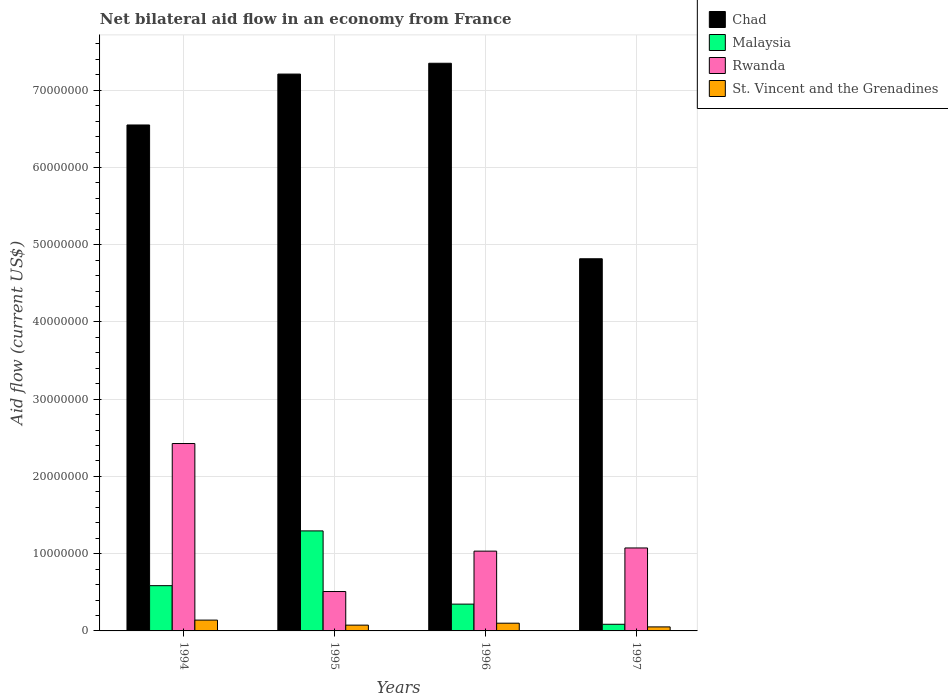How many groups of bars are there?
Your answer should be compact. 4. What is the label of the 2nd group of bars from the left?
Make the answer very short. 1995. What is the net bilateral aid flow in Chad in 1997?
Give a very brief answer. 4.82e+07. Across all years, what is the maximum net bilateral aid flow in Rwanda?
Offer a terse response. 2.43e+07. Across all years, what is the minimum net bilateral aid flow in Rwanda?
Ensure brevity in your answer.  5.10e+06. In which year was the net bilateral aid flow in Chad minimum?
Offer a terse response. 1997. What is the total net bilateral aid flow in Rwanda in the graph?
Your answer should be very brief. 5.04e+07. What is the difference between the net bilateral aid flow in St. Vincent and the Grenadines in 1996 and that in 1997?
Your answer should be very brief. 4.80e+05. What is the difference between the net bilateral aid flow in Malaysia in 1994 and the net bilateral aid flow in Chad in 1995?
Your response must be concise. -6.62e+07. What is the average net bilateral aid flow in Chad per year?
Keep it short and to the point. 6.48e+07. In the year 1994, what is the difference between the net bilateral aid flow in Malaysia and net bilateral aid flow in St. Vincent and the Grenadines?
Your answer should be compact. 4.46e+06. In how many years, is the net bilateral aid flow in Chad greater than 54000000 US$?
Your answer should be very brief. 3. What is the ratio of the net bilateral aid flow in St. Vincent and the Grenadines in 1994 to that in 1995?
Offer a terse response. 1.87. Is the net bilateral aid flow in Malaysia in 1994 less than that in 1997?
Offer a terse response. No. What is the difference between the highest and the second highest net bilateral aid flow in Malaysia?
Give a very brief answer. 7.09e+06. What is the difference between the highest and the lowest net bilateral aid flow in Chad?
Make the answer very short. 2.53e+07. Is the sum of the net bilateral aid flow in Chad in 1995 and 1997 greater than the maximum net bilateral aid flow in Malaysia across all years?
Keep it short and to the point. Yes. Is it the case that in every year, the sum of the net bilateral aid flow in Chad and net bilateral aid flow in St. Vincent and the Grenadines is greater than the sum of net bilateral aid flow in Rwanda and net bilateral aid flow in Malaysia?
Give a very brief answer. Yes. What does the 1st bar from the left in 1994 represents?
Offer a very short reply. Chad. What does the 4th bar from the right in 1995 represents?
Offer a very short reply. Chad. Are all the bars in the graph horizontal?
Your answer should be compact. No. How many years are there in the graph?
Ensure brevity in your answer.  4. What is the difference between two consecutive major ticks on the Y-axis?
Provide a succinct answer. 1.00e+07. Does the graph contain any zero values?
Make the answer very short. No. Does the graph contain grids?
Make the answer very short. Yes. Where does the legend appear in the graph?
Your answer should be compact. Top right. How many legend labels are there?
Give a very brief answer. 4. How are the legend labels stacked?
Offer a very short reply. Vertical. What is the title of the graph?
Ensure brevity in your answer.  Net bilateral aid flow in an economy from France. What is the label or title of the X-axis?
Offer a terse response. Years. What is the label or title of the Y-axis?
Ensure brevity in your answer.  Aid flow (current US$). What is the Aid flow (current US$) in Chad in 1994?
Provide a short and direct response. 6.55e+07. What is the Aid flow (current US$) of Malaysia in 1994?
Provide a short and direct response. 5.86e+06. What is the Aid flow (current US$) of Rwanda in 1994?
Your response must be concise. 2.43e+07. What is the Aid flow (current US$) of St. Vincent and the Grenadines in 1994?
Your response must be concise. 1.40e+06. What is the Aid flow (current US$) in Chad in 1995?
Offer a terse response. 7.21e+07. What is the Aid flow (current US$) in Malaysia in 1995?
Your answer should be compact. 1.30e+07. What is the Aid flow (current US$) of Rwanda in 1995?
Offer a terse response. 5.10e+06. What is the Aid flow (current US$) in St. Vincent and the Grenadines in 1995?
Give a very brief answer. 7.50e+05. What is the Aid flow (current US$) of Chad in 1996?
Ensure brevity in your answer.  7.35e+07. What is the Aid flow (current US$) of Malaysia in 1996?
Your answer should be very brief. 3.47e+06. What is the Aid flow (current US$) of Rwanda in 1996?
Your answer should be compact. 1.03e+07. What is the Aid flow (current US$) in St. Vincent and the Grenadines in 1996?
Your answer should be compact. 1.00e+06. What is the Aid flow (current US$) of Chad in 1997?
Your answer should be compact. 4.82e+07. What is the Aid flow (current US$) of Malaysia in 1997?
Provide a short and direct response. 8.60e+05. What is the Aid flow (current US$) of Rwanda in 1997?
Ensure brevity in your answer.  1.07e+07. What is the Aid flow (current US$) of St. Vincent and the Grenadines in 1997?
Your response must be concise. 5.20e+05. Across all years, what is the maximum Aid flow (current US$) of Chad?
Give a very brief answer. 7.35e+07. Across all years, what is the maximum Aid flow (current US$) in Malaysia?
Provide a short and direct response. 1.30e+07. Across all years, what is the maximum Aid flow (current US$) of Rwanda?
Your answer should be very brief. 2.43e+07. Across all years, what is the maximum Aid flow (current US$) of St. Vincent and the Grenadines?
Provide a short and direct response. 1.40e+06. Across all years, what is the minimum Aid flow (current US$) in Chad?
Provide a succinct answer. 4.82e+07. Across all years, what is the minimum Aid flow (current US$) of Malaysia?
Provide a succinct answer. 8.60e+05. Across all years, what is the minimum Aid flow (current US$) of Rwanda?
Offer a very short reply. 5.10e+06. Across all years, what is the minimum Aid flow (current US$) of St. Vincent and the Grenadines?
Your answer should be very brief. 5.20e+05. What is the total Aid flow (current US$) in Chad in the graph?
Offer a terse response. 2.59e+08. What is the total Aid flow (current US$) of Malaysia in the graph?
Ensure brevity in your answer.  2.31e+07. What is the total Aid flow (current US$) of Rwanda in the graph?
Ensure brevity in your answer.  5.04e+07. What is the total Aid flow (current US$) in St. Vincent and the Grenadines in the graph?
Your answer should be compact. 3.67e+06. What is the difference between the Aid flow (current US$) in Chad in 1994 and that in 1995?
Offer a very short reply. -6.59e+06. What is the difference between the Aid flow (current US$) in Malaysia in 1994 and that in 1995?
Offer a very short reply. -7.09e+06. What is the difference between the Aid flow (current US$) in Rwanda in 1994 and that in 1995?
Make the answer very short. 1.92e+07. What is the difference between the Aid flow (current US$) of St. Vincent and the Grenadines in 1994 and that in 1995?
Your answer should be compact. 6.50e+05. What is the difference between the Aid flow (current US$) of Chad in 1994 and that in 1996?
Your response must be concise. -7.99e+06. What is the difference between the Aid flow (current US$) in Malaysia in 1994 and that in 1996?
Give a very brief answer. 2.39e+06. What is the difference between the Aid flow (current US$) of Rwanda in 1994 and that in 1996?
Give a very brief answer. 1.39e+07. What is the difference between the Aid flow (current US$) in Chad in 1994 and that in 1997?
Provide a succinct answer. 1.73e+07. What is the difference between the Aid flow (current US$) of Malaysia in 1994 and that in 1997?
Your answer should be compact. 5.00e+06. What is the difference between the Aid flow (current US$) in Rwanda in 1994 and that in 1997?
Give a very brief answer. 1.35e+07. What is the difference between the Aid flow (current US$) of St. Vincent and the Grenadines in 1994 and that in 1997?
Offer a terse response. 8.80e+05. What is the difference between the Aid flow (current US$) in Chad in 1995 and that in 1996?
Give a very brief answer. -1.40e+06. What is the difference between the Aid flow (current US$) of Malaysia in 1995 and that in 1996?
Provide a short and direct response. 9.48e+06. What is the difference between the Aid flow (current US$) in Rwanda in 1995 and that in 1996?
Provide a succinct answer. -5.23e+06. What is the difference between the Aid flow (current US$) in St. Vincent and the Grenadines in 1995 and that in 1996?
Provide a succinct answer. -2.50e+05. What is the difference between the Aid flow (current US$) of Chad in 1995 and that in 1997?
Provide a short and direct response. 2.39e+07. What is the difference between the Aid flow (current US$) of Malaysia in 1995 and that in 1997?
Give a very brief answer. 1.21e+07. What is the difference between the Aid flow (current US$) in Rwanda in 1995 and that in 1997?
Offer a terse response. -5.64e+06. What is the difference between the Aid flow (current US$) in St. Vincent and the Grenadines in 1995 and that in 1997?
Offer a terse response. 2.30e+05. What is the difference between the Aid flow (current US$) of Chad in 1996 and that in 1997?
Your answer should be compact. 2.53e+07. What is the difference between the Aid flow (current US$) in Malaysia in 1996 and that in 1997?
Offer a very short reply. 2.61e+06. What is the difference between the Aid flow (current US$) of Rwanda in 1996 and that in 1997?
Make the answer very short. -4.10e+05. What is the difference between the Aid flow (current US$) in St. Vincent and the Grenadines in 1996 and that in 1997?
Ensure brevity in your answer.  4.80e+05. What is the difference between the Aid flow (current US$) of Chad in 1994 and the Aid flow (current US$) of Malaysia in 1995?
Give a very brief answer. 5.26e+07. What is the difference between the Aid flow (current US$) in Chad in 1994 and the Aid flow (current US$) in Rwanda in 1995?
Give a very brief answer. 6.04e+07. What is the difference between the Aid flow (current US$) in Chad in 1994 and the Aid flow (current US$) in St. Vincent and the Grenadines in 1995?
Keep it short and to the point. 6.48e+07. What is the difference between the Aid flow (current US$) in Malaysia in 1994 and the Aid flow (current US$) in Rwanda in 1995?
Your answer should be compact. 7.60e+05. What is the difference between the Aid flow (current US$) in Malaysia in 1994 and the Aid flow (current US$) in St. Vincent and the Grenadines in 1995?
Offer a terse response. 5.11e+06. What is the difference between the Aid flow (current US$) of Rwanda in 1994 and the Aid flow (current US$) of St. Vincent and the Grenadines in 1995?
Give a very brief answer. 2.35e+07. What is the difference between the Aid flow (current US$) of Chad in 1994 and the Aid flow (current US$) of Malaysia in 1996?
Your response must be concise. 6.20e+07. What is the difference between the Aid flow (current US$) of Chad in 1994 and the Aid flow (current US$) of Rwanda in 1996?
Offer a very short reply. 5.52e+07. What is the difference between the Aid flow (current US$) in Chad in 1994 and the Aid flow (current US$) in St. Vincent and the Grenadines in 1996?
Give a very brief answer. 6.45e+07. What is the difference between the Aid flow (current US$) in Malaysia in 1994 and the Aid flow (current US$) in Rwanda in 1996?
Provide a succinct answer. -4.47e+06. What is the difference between the Aid flow (current US$) in Malaysia in 1994 and the Aid flow (current US$) in St. Vincent and the Grenadines in 1996?
Provide a short and direct response. 4.86e+06. What is the difference between the Aid flow (current US$) of Rwanda in 1994 and the Aid flow (current US$) of St. Vincent and the Grenadines in 1996?
Provide a succinct answer. 2.33e+07. What is the difference between the Aid flow (current US$) in Chad in 1994 and the Aid flow (current US$) in Malaysia in 1997?
Ensure brevity in your answer.  6.46e+07. What is the difference between the Aid flow (current US$) of Chad in 1994 and the Aid flow (current US$) of Rwanda in 1997?
Make the answer very short. 5.48e+07. What is the difference between the Aid flow (current US$) of Chad in 1994 and the Aid flow (current US$) of St. Vincent and the Grenadines in 1997?
Give a very brief answer. 6.50e+07. What is the difference between the Aid flow (current US$) of Malaysia in 1994 and the Aid flow (current US$) of Rwanda in 1997?
Make the answer very short. -4.88e+06. What is the difference between the Aid flow (current US$) in Malaysia in 1994 and the Aid flow (current US$) in St. Vincent and the Grenadines in 1997?
Make the answer very short. 5.34e+06. What is the difference between the Aid flow (current US$) of Rwanda in 1994 and the Aid flow (current US$) of St. Vincent and the Grenadines in 1997?
Give a very brief answer. 2.37e+07. What is the difference between the Aid flow (current US$) of Chad in 1995 and the Aid flow (current US$) of Malaysia in 1996?
Ensure brevity in your answer.  6.86e+07. What is the difference between the Aid flow (current US$) of Chad in 1995 and the Aid flow (current US$) of Rwanda in 1996?
Provide a short and direct response. 6.18e+07. What is the difference between the Aid flow (current US$) of Chad in 1995 and the Aid flow (current US$) of St. Vincent and the Grenadines in 1996?
Offer a terse response. 7.11e+07. What is the difference between the Aid flow (current US$) in Malaysia in 1995 and the Aid flow (current US$) in Rwanda in 1996?
Make the answer very short. 2.62e+06. What is the difference between the Aid flow (current US$) in Malaysia in 1995 and the Aid flow (current US$) in St. Vincent and the Grenadines in 1996?
Offer a very short reply. 1.20e+07. What is the difference between the Aid flow (current US$) of Rwanda in 1995 and the Aid flow (current US$) of St. Vincent and the Grenadines in 1996?
Offer a terse response. 4.10e+06. What is the difference between the Aid flow (current US$) in Chad in 1995 and the Aid flow (current US$) in Malaysia in 1997?
Offer a terse response. 7.12e+07. What is the difference between the Aid flow (current US$) of Chad in 1995 and the Aid flow (current US$) of Rwanda in 1997?
Your answer should be very brief. 6.14e+07. What is the difference between the Aid flow (current US$) of Chad in 1995 and the Aid flow (current US$) of St. Vincent and the Grenadines in 1997?
Your answer should be very brief. 7.16e+07. What is the difference between the Aid flow (current US$) in Malaysia in 1995 and the Aid flow (current US$) in Rwanda in 1997?
Your answer should be compact. 2.21e+06. What is the difference between the Aid flow (current US$) in Malaysia in 1995 and the Aid flow (current US$) in St. Vincent and the Grenadines in 1997?
Offer a very short reply. 1.24e+07. What is the difference between the Aid flow (current US$) of Rwanda in 1995 and the Aid flow (current US$) of St. Vincent and the Grenadines in 1997?
Keep it short and to the point. 4.58e+06. What is the difference between the Aid flow (current US$) in Chad in 1996 and the Aid flow (current US$) in Malaysia in 1997?
Your answer should be compact. 7.26e+07. What is the difference between the Aid flow (current US$) in Chad in 1996 and the Aid flow (current US$) in Rwanda in 1997?
Your answer should be compact. 6.28e+07. What is the difference between the Aid flow (current US$) of Chad in 1996 and the Aid flow (current US$) of St. Vincent and the Grenadines in 1997?
Keep it short and to the point. 7.30e+07. What is the difference between the Aid flow (current US$) in Malaysia in 1996 and the Aid flow (current US$) in Rwanda in 1997?
Give a very brief answer. -7.27e+06. What is the difference between the Aid flow (current US$) in Malaysia in 1996 and the Aid flow (current US$) in St. Vincent and the Grenadines in 1997?
Your answer should be compact. 2.95e+06. What is the difference between the Aid flow (current US$) in Rwanda in 1996 and the Aid flow (current US$) in St. Vincent and the Grenadines in 1997?
Offer a very short reply. 9.81e+06. What is the average Aid flow (current US$) of Chad per year?
Offer a very short reply. 6.48e+07. What is the average Aid flow (current US$) of Malaysia per year?
Your answer should be very brief. 5.78e+06. What is the average Aid flow (current US$) in Rwanda per year?
Offer a terse response. 1.26e+07. What is the average Aid flow (current US$) in St. Vincent and the Grenadines per year?
Ensure brevity in your answer.  9.18e+05. In the year 1994, what is the difference between the Aid flow (current US$) in Chad and Aid flow (current US$) in Malaysia?
Keep it short and to the point. 5.96e+07. In the year 1994, what is the difference between the Aid flow (current US$) in Chad and Aid flow (current US$) in Rwanda?
Offer a terse response. 4.12e+07. In the year 1994, what is the difference between the Aid flow (current US$) of Chad and Aid flow (current US$) of St. Vincent and the Grenadines?
Ensure brevity in your answer.  6.41e+07. In the year 1994, what is the difference between the Aid flow (current US$) in Malaysia and Aid flow (current US$) in Rwanda?
Your response must be concise. -1.84e+07. In the year 1994, what is the difference between the Aid flow (current US$) in Malaysia and Aid flow (current US$) in St. Vincent and the Grenadines?
Offer a terse response. 4.46e+06. In the year 1994, what is the difference between the Aid flow (current US$) in Rwanda and Aid flow (current US$) in St. Vincent and the Grenadines?
Give a very brief answer. 2.29e+07. In the year 1995, what is the difference between the Aid flow (current US$) in Chad and Aid flow (current US$) in Malaysia?
Keep it short and to the point. 5.91e+07. In the year 1995, what is the difference between the Aid flow (current US$) of Chad and Aid flow (current US$) of Rwanda?
Provide a succinct answer. 6.70e+07. In the year 1995, what is the difference between the Aid flow (current US$) in Chad and Aid flow (current US$) in St. Vincent and the Grenadines?
Provide a succinct answer. 7.13e+07. In the year 1995, what is the difference between the Aid flow (current US$) in Malaysia and Aid flow (current US$) in Rwanda?
Make the answer very short. 7.85e+06. In the year 1995, what is the difference between the Aid flow (current US$) in Malaysia and Aid flow (current US$) in St. Vincent and the Grenadines?
Provide a succinct answer. 1.22e+07. In the year 1995, what is the difference between the Aid flow (current US$) of Rwanda and Aid flow (current US$) of St. Vincent and the Grenadines?
Your response must be concise. 4.35e+06. In the year 1996, what is the difference between the Aid flow (current US$) in Chad and Aid flow (current US$) in Malaysia?
Provide a short and direct response. 7.00e+07. In the year 1996, what is the difference between the Aid flow (current US$) in Chad and Aid flow (current US$) in Rwanda?
Offer a very short reply. 6.32e+07. In the year 1996, what is the difference between the Aid flow (current US$) of Chad and Aid flow (current US$) of St. Vincent and the Grenadines?
Your response must be concise. 7.25e+07. In the year 1996, what is the difference between the Aid flow (current US$) of Malaysia and Aid flow (current US$) of Rwanda?
Make the answer very short. -6.86e+06. In the year 1996, what is the difference between the Aid flow (current US$) of Malaysia and Aid flow (current US$) of St. Vincent and the Grenadines?
Offer a terse response. 2.47e+06. In the year 1996, what is the difference between the Aid flow (current US$) in Rwanda and Aid flow (current US$) in St. Vincent and the Grenadines?
Give a very brief answer. 9.33e+06. In the year 1997, what is the difference between the Aid flow (current US$) in Chad and Aid flow (current US$) in Malaysia?
Your response must be concise. 4.73e+07. In the year 1997, what is the difference between the Aid flow (current US$) in Chad and Aid flow (current US$) in Rwanda?
Your response must be concise. 3.74e+07. In the year 1997, what is the difference between the Aid flow (current US$) in Chad and Aid flow (current US$) in St. Vincent and the Grenadines?
Your response must be concise. 4.77e+07. In the year 1997, what is the difference between the Aid flow (current US$) in Malaysia and Aid flow (current US$) in Rwanda?
Your answer should be compact. -9.88e+06. In the year 1997, what is the difference between the Aid flow (current US$) of Malaysia and Aid flow (current US$) of St. Vincent and the Grenadines?
Give a very brief answer. 3.40e+05. In the year 1997, what is the difference between the Aid flow (current US$) in Rwanda and Aid flow (current US$) in St. Vincent and the Grenadines?
Your answer should be very brief. 1.02e+07. What is the ratio of the Aid flow (current US$) of Chad in 1994 to that in 1995?
Provide a succinct answer. 0.91. What is the ratio of the Aid flow (current US$) in Malaysia in 1994 to that in 1995?
Ensure brevity in your answer.  0.45. What is the ratio of the Aid flow (current US$) of Rwanda in 1994 to that in 1995?
Provide a succinct answer. 4.76. What is the ratio of the Aid flow (current US$) in St. Vincent and the Grenadines in 1994 to that in 1995?
Provide a succinct answer. 1.87. What is the ratio of the Aid flow (current US$) in Chad in 1994 to that in 1996?
Ensure brevity in your answer.  0.89. What is the ratio of the Aid flow (current US$) in Malaysia in 1994 to that in 1996?
Make the answer very short. 1.69. What is the ratio of the Aid flow (current US$) of Rwanda in 1994 to that in 1996?
Your response must be concise. 2.35. What is the ratio of the Aid flow (current US$) of St. Vincent and the Grenadines in 1994 to that in 1996?
Your answer should be compact. 1.4. What is the ratio of the Aid flow (current US$) of Chad in 1994 to that in 1997?
Make the answer very short. 1.36. What is the ratio of the Aid flow (current US$) of Malaysia in 1994 to that in 1997?
Ensure brevity in your answer.  6.81. What is the ratio of the Aid flow (current US$) in Rwanda in 1994 to that in 1997?
Keep it short and to the point. 2.26. What is the ratio of the Aid flow (current US$) of St. Vincent and the Grenadines in 1994 to that in 1997?
Provide a succinct answer. 2.69. What is the ratio of the Aid flow (current US$) in Chad in 1995 to that in 1996?
Provide a short and direct response. 0.98. What is the ratio of the Aid flow (current US$) of Malaysia in 1995 to that in 1996?
Make the answer very short. 3.73. What is the ratio of the Aid flow (current US$) of Rwanda in 1995 to that in 1996?
Ensure brevity in your answer.  0.49. What is the ratio of the Aid flow (current US$) of Chad in 1995 to that in 1997?
Give a very brief answer. 1.5. What is the ratio of the Aid flow (current US$) in Malaysia in 1995 to that in 1997?
Make the answer very short. 15.06. What is the ratio of the Aid flow (current US$) in Rwanda in 1995 to that in 1997?
Your response must be concise. 0.47. What is the ratio of the Aid flow (current US$) of St. Vincent and the Grenadines in 1995 to that in 1997?
Your answer should be compact. 1.44. What is the ratio of the Aid flow (current US$) of Chad in 1996 to that in 1997?
Give a very brief answer. 1.53. What is the ratio of the Aid flow (current US$) of Malaysia in 1996 to that in 1997?
Give a very brief answer. 4.03. What is the ratio of the Aid flow (current US$) of Rwanda in 1996 to that in 1997?
Keep it short and to the point. 0.96. What is the ratio of the Aid flow (current US$) of St. Vincent and the Grenadines in 1996 to that in 1997?
Keep it short and to the point. 1.92. What is the difference between the highest and the second highest Aid flow (current US$) of Chad?
Provide a succinct answer. 1.40e+06. What is the difference between the highest and the second highest Aid flow (current US$) of Malaysia?
Ensure brevity in your answer.  7.09e+06. What is the difference between the highest and the second highest Aid flow (current US$) in Rwanda?
Ensure brevity in your answer.  1.35e+07. What is the difference between the highest and the lowest Aid flow (current US$) of Chad?
Give a very brief answer. 2.53e+07. What is the difference between the highest and the lowest Aid flow (current US$) in Malaysia?
Provide a succinct answer. 1.21e+07. What is the difference between the highest and the lowest Aid flow (current US$) of Rwanda?
Make the answer very short. 1.92e+07. What is the difference between the highest and the lowest Aid flow (current US$) of St. Vincent and the Grenadines?
Offer a very short reply. 8.80e+05. 